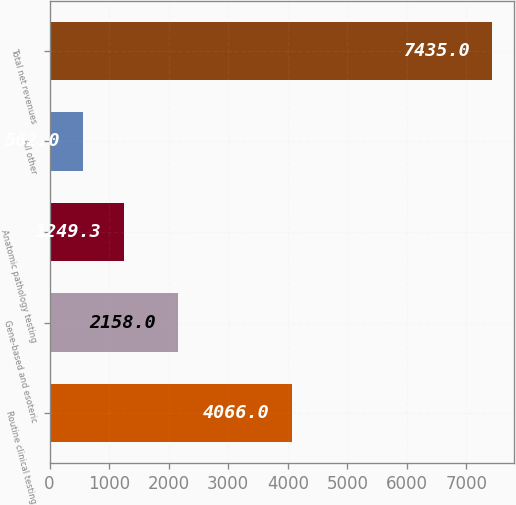Convert chart to OTSL. <chart><loc_0><loc_0><loc_500><loc_500><bar_chart><fcel>Routine clinical testing<fcel>Gene-based and esoteric<fcel>Anatomic pathology testing<fcel>All other<fcel>Total net revenues<nl><fcel>4066<fcel>2158<fcel>1249.3<fcel>562<fcel>7435<nl></chart> 